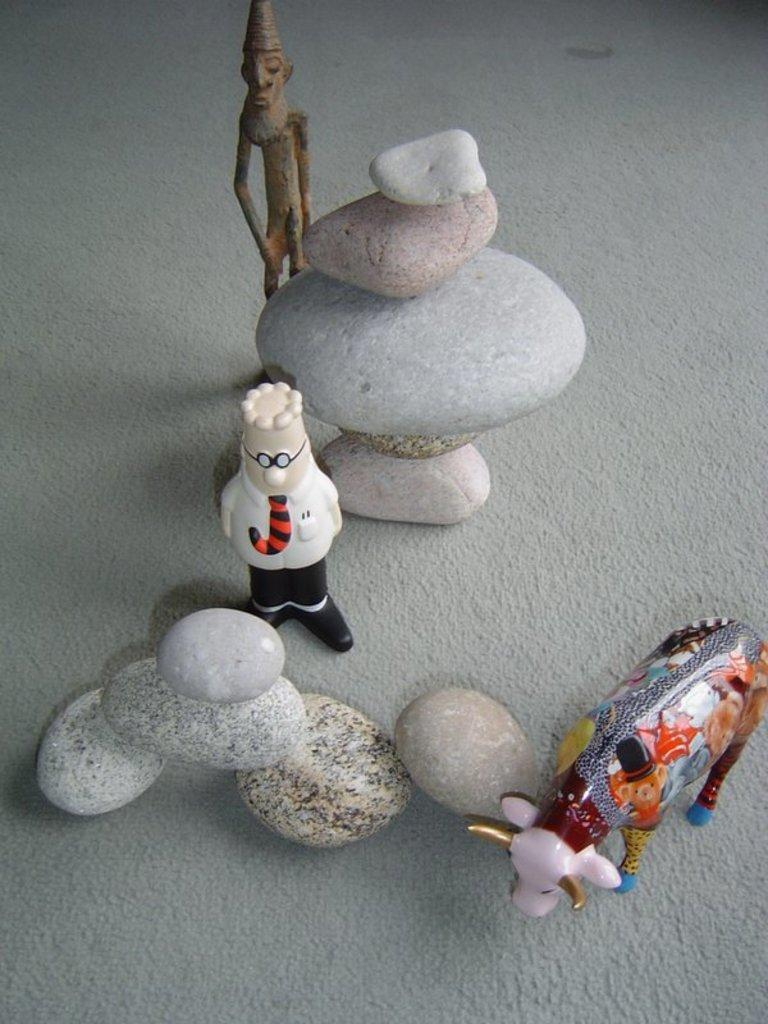What objects are on the surface in the image? There are stones and toys on the surface in the image. Can you describe the stones in the image? The stones are on the surface, but no further details about their size, shape, or color are provided. What type of toys can be seen on the surface? The toys on the surface are not described in detail, so it is not possible to identify their specific type. What type of net can be seen catching waves in the image? There is no net or waves present in the image; it features stones and toys on a surface. Is there a toothbrush visible among the stones and toys in the image? There is no toothbrush present in the image. 